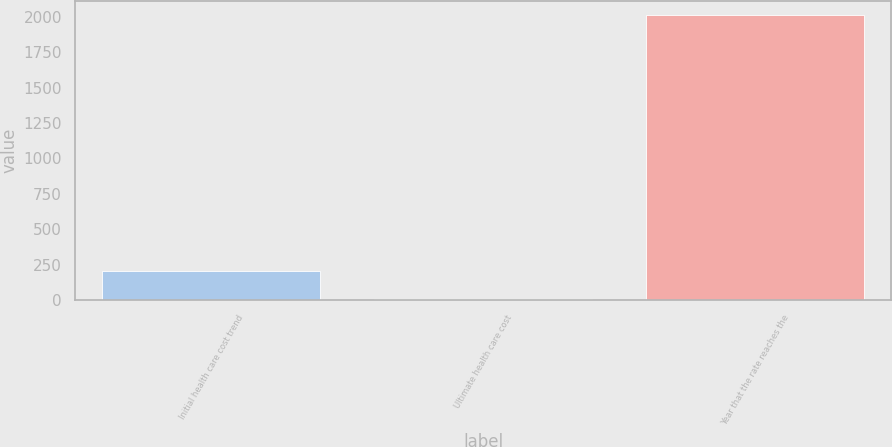Convert chart. <chart><loc_0><loc_0><loc_500><loc_500><bar_chart><fcel>Initial health care cost trend<fcel>Ultimate health care cost<fcel>Year that the rate reaches the<nl><fcel>205.8<fcel>5<fcel>2013<nl></chart> 